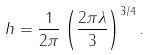<formula> <loc_0><loc_0><loc_500><loc_500>h = \frac { 1 } { 2 \pi } \left ( \frac { 2 \pi \lambda } { 3 } \right ) ^ { 3 / 4 } .</formula> 